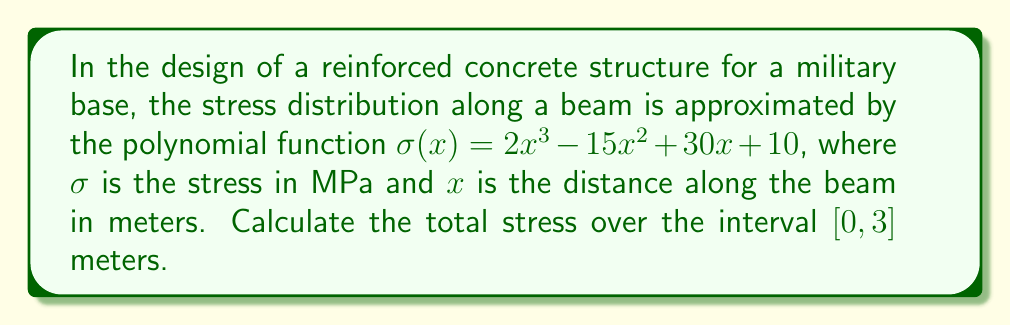Show me your answer to this math problem. To find the total stress over the interval, we need to integrate the stress function from 0 to 3 meters:

1) Set up the definite integral:
   $$\int_0^3 (2x^3 - 15x^2 + 30x + 10) dx$$

2) Integrate the polynomial term by term:
   $$\left[\frac{1}{2}x^4 - 5x^3 + 15x^2 + 10x\right]_0^3$$

3) Evaluate the integral at the upper and lower bounds:
   Upper bound (x = 3):
   $$\frac{1}{2}(3^4) - 5(3^3) + 15(3^2) + 10(3) = 40.5 - 135 + 135 + 30 = 70.5$$
   
   Lower bound (x = 0):
   $$\frac{1}{2}(0^4) - 5(0^3) + 15(0^2) + 10(0) = 0$$

4) Subtract the lower bound from the upper bound:
   $$70.5 - 0 = 70.5$$

The total stress over the interval [0, 3] meters is 70.5 MPa·m.
Answer: 70.5 MPa·m 